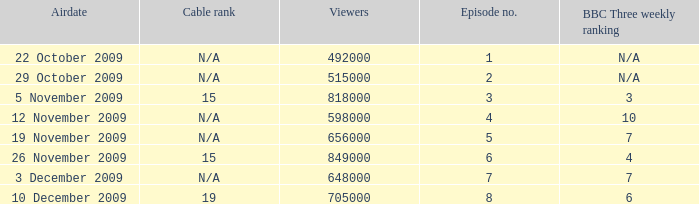How many entries are shown for viewers when the airdate was 26 november 2009? 1.0. 